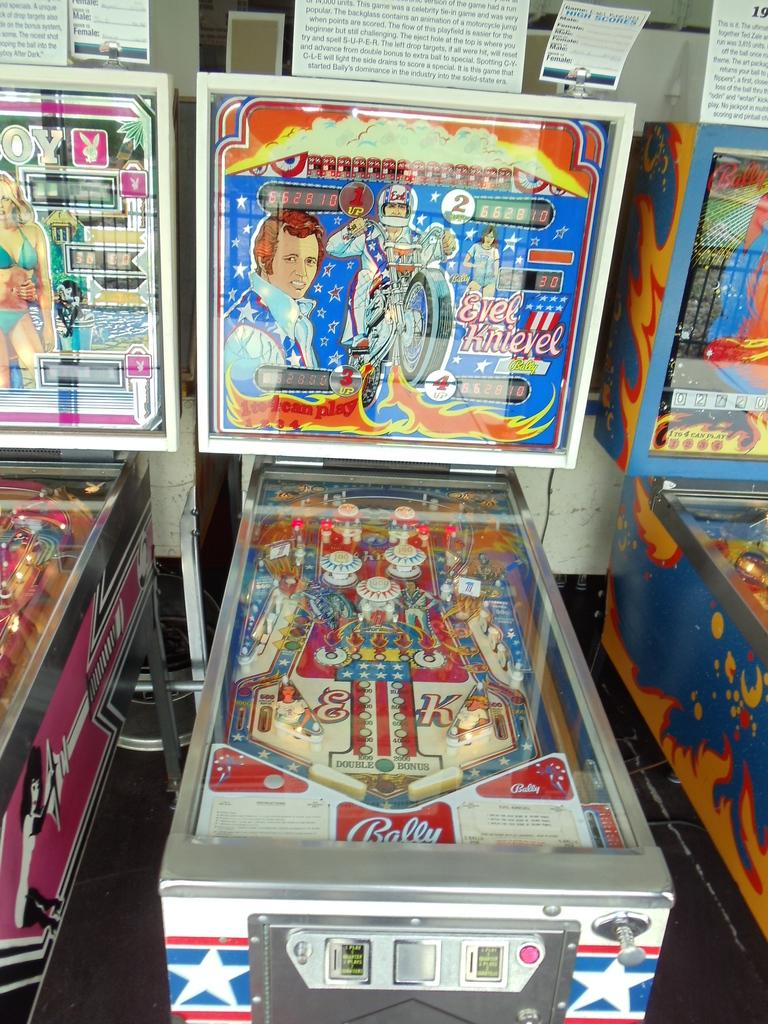<image>
Create a compact narrative representing the image presented. Pinball machine showing a person on a motor bike and the name "EVEL KNIEVEL". 